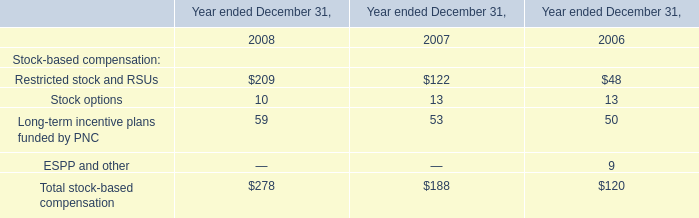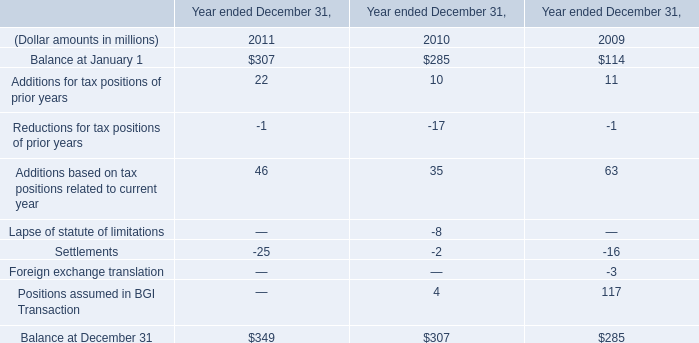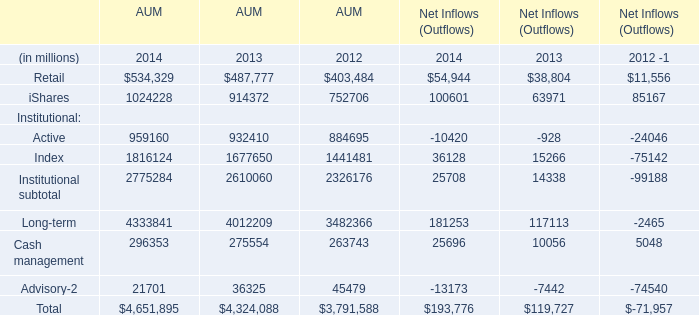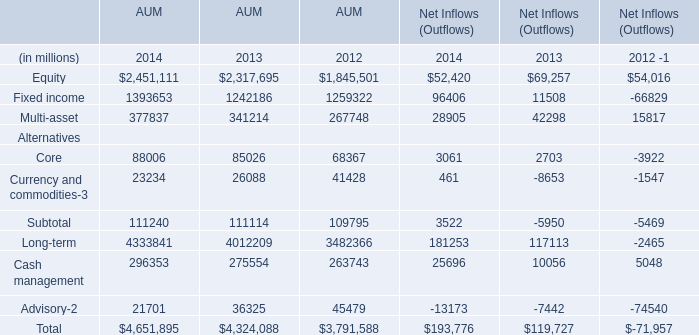What's the sum of AUM in 2014? (in millions) 
Answer: 4651895. 